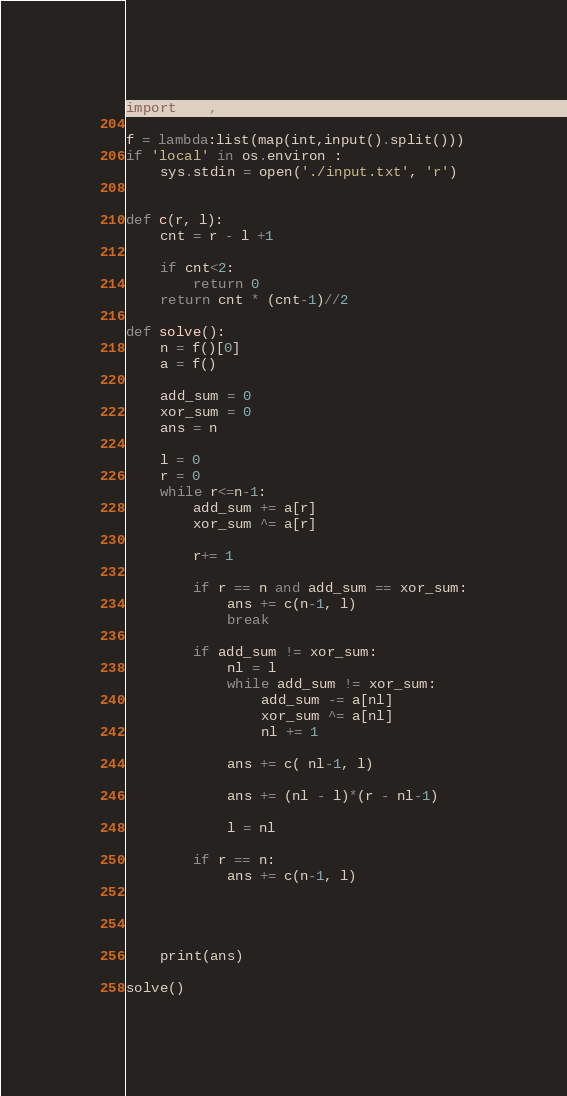<code> <loc_0><loc_0><loc_500><loc_500><_Python_>import sys, os

f = lambda:list(map(int,input().split()))
if 'local' in os.environ :
    sys.stdin = open('./input.txt', 'r')


def c(r, l):
    cnt = r - l +1

    if cnt<2:
        return 0
    return cnt * (cnt-1)//2

def solve():
    n = f()[0]
    a = f()

    add_sum = 0
    xor_sum = 0
    ans = n

    l = 0
    r = 0
    while r<=n-1:
        add_sum += a[r]
        xor_sum ^= a[r]

        r+= 1

        if r == n and add_sum == xor_sum:
            ans += c(n-1, l)
            break

        if add_sum != xor_sum:
            nl = l
            while add_sum != xor_sum:
                add_sum -= a[nl]
                xor_sum ^= a[nl]
                nl += 1
            
            ans += c( nl-1, l)

            ans += (nl - l)*(r - nl-1)

            l = nl

        if r == n:
            ans += c(n-1, l)




    print(ans)

solve()
</code> 